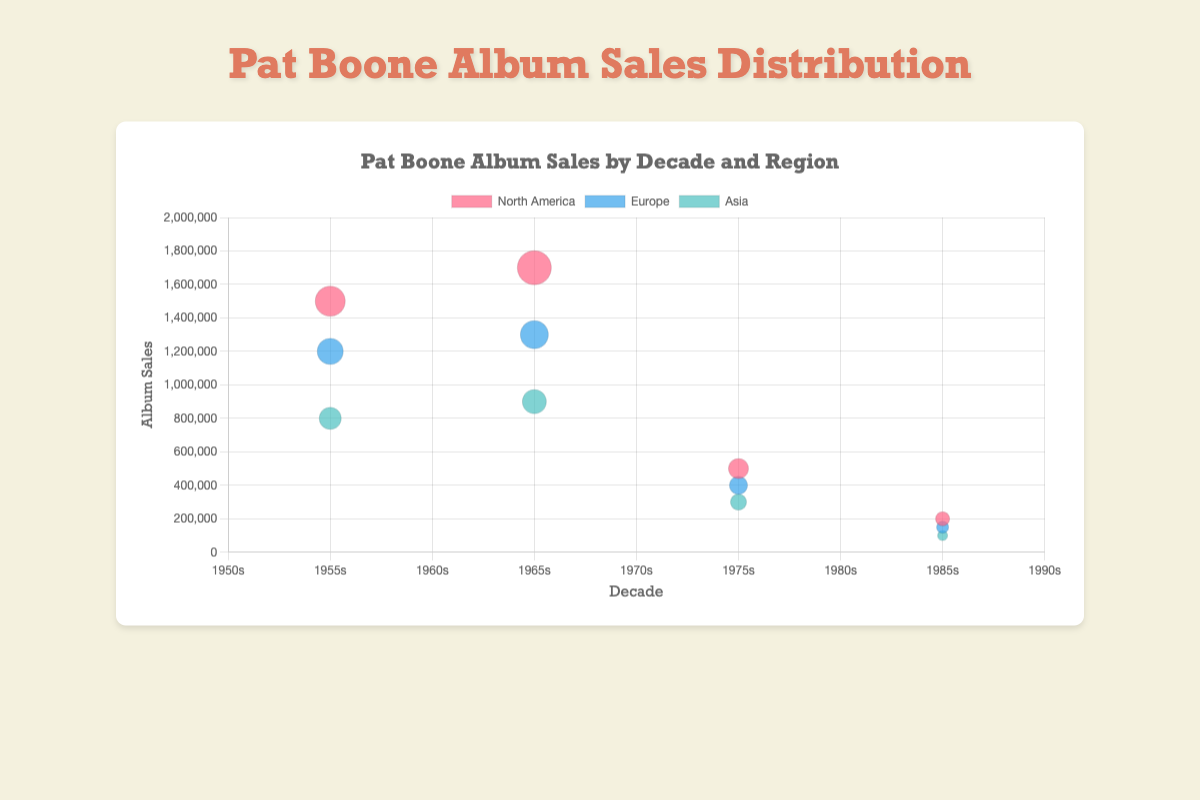What is the title of the bubble chart? The title of the chart is displayed at the top in larger, highlighted text. It reads, "Pat Boone Album Sales by Decade and Region."
Answer: Pat Boone Album Sales by Decade and Region Which region had the highest album sales in the 1960s? By observing the vertical axis (album sales) and the bubble size, the highest point and the biggest bubble in the 1960s correspond to the data point for North America.
Answer: North America How do album sales in North America compare between the 1950s and 1970s? Look at the bubble sizes and their positions along the vertical axis for North America in the 1950s and 1970s. The 1950s show 1,500,000 sales, while the 1970s show 500,000 sales. North American sales dropped significantly from the 1950s to the 1970s.
Answer: The sales decreased What is the total album sales in Asia across all decades shown? Add the album sales from the 1950s, 1960s, 1970s, and 1980s in Asia: 800,000 + 900,000 + 300,000 + 100,000.
Answer: 2,100,000 Which decade shows the least album sales for Europe, and what are the sales figures for that decade? Identify the smallest bubble for Europe by looking at the vertical axis (album sales) and the bubble size. The 1980s have the smallest bubble, showing 150,000 sales.
Answer: 1980s, 150,000 What is the average album sales in North America across all decades shown? Calculate the average by summing the sales in North America across all decades (1950s, 1960s, 1970s, 1980s) and divide by the number of decades: (1,500,000 + 1,700,000 + 500,000 + 200,000) / 4.
Answer: 975,000 In which decade did album sales in Asia peak, and what were the sales figures? The largest bubble for Asia, and the highest point on the y-axis for Asia, corresponds to the 1960s, showing 900,000 sales.
Answer: 1960s, 900,000 How much did album sales in Europe change from the 1950s to the 1960s? Find the album sales in Europe for the 1950s and 1960s from the chart, then subtract the two: 1,300,000 - 1,200,000.
Answer: 100,000 increase 